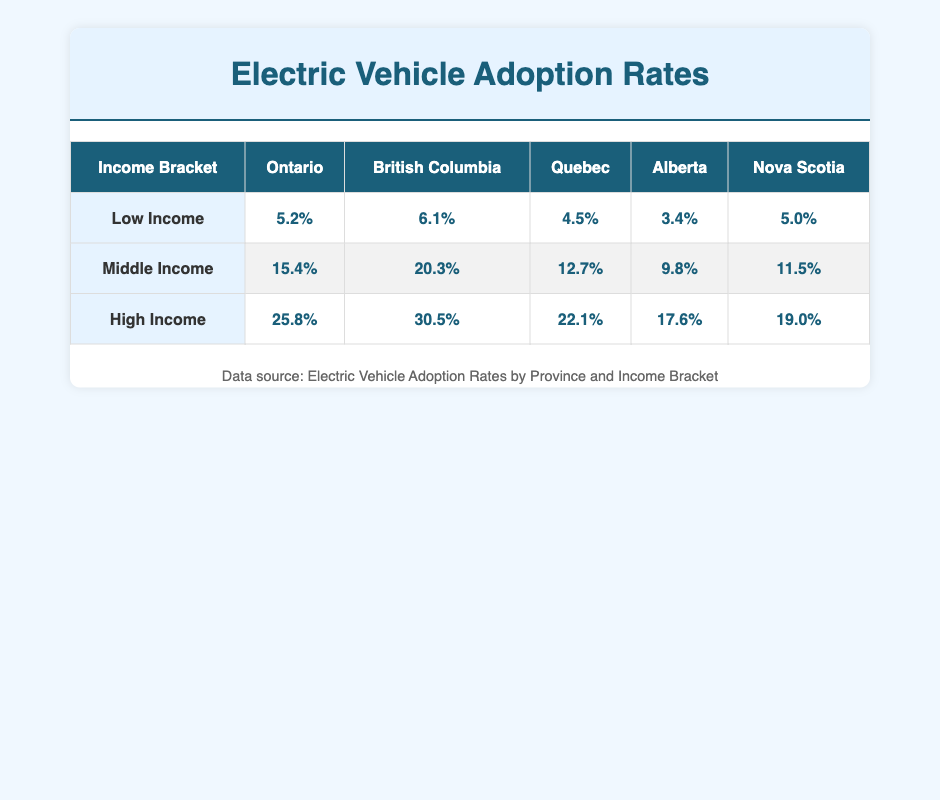What is the adoption rate for High Income individuals in Ontario? Referring to the table, the adoption rate for High Income individuals in Ontario is listed directly. It is 25.8%.
Answer: 25.8% Which province has the highest adoption rate for Low Income? By comparing the adoption rates for Low Income individuals across provinces, British Columbia has the highest rate at 6.1%.
Answer: British Columbia What is the average adoption rate for Middle Income individuals across all provinces? To find the average, sum the Middle Income adoption rates (15.4% + 20.3% + 12.7% + 9.8% + 11.5% = 69.7%) and divide by the number of provinces (5). Thus, the average is 69.7% / 5 = 13.94%.
Answer: 13.94% Is the adoption rate for Middle Income individuals in Alberta greater than that in Nova Scotia? Checking the table, the adoption rate for Middle Income in Alberta is 9.8%, while in Nova Scotia it is 11.5%. Since 9.8% is less than 11.5%, the statement is false.
Answer: No What is the difference in adoption rates between High Income in British Columbia and High Income in Alberta? The adoption rate for High Income in British Columbia is 30.5%, and in Alberta, it is 17.6%. The difference is 30.5% - 17.6% = 12.9%.
Answer: 12.9% Which province has the lowest adoption rate for Low Income? The table shows that Alberta has the lowest adoption rate for Low Income at 3.4%. Therefore, the answer is Alberta.
Answer: Alberta Is the adoption rate for Low Income individuals higher in Nova Scotia than in Quebec? Comparing the rates, Nova Scotia has a rate of 5.0%, and Quebec has 4.5%. Since 5.0% is greater than 4.5%, the answer is yes.
Answer: Yes What is the total adoption rate for High Income across all provinces? To find the total, add all High Income adoption rates: (25.8% + 30.5% + 22.1% + 17.6% + 19.0% = 115.0%). Therefore, the total adoption rate for High Income is 115.0%.
Answer: 115.0% 